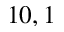<formula> <loc_0><loc_0><loc_500><loc_500>1 0 , 1</formula> 